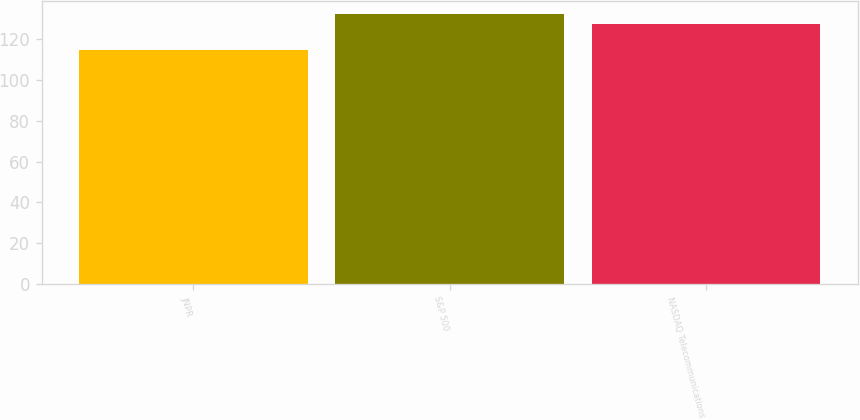Convert chart. <chart><loc_0><loc_0><loc_500><loc_500><bar_chart><fcel>JNPR<fcel>S&P 500<fcel>NASDAQ Telecommunications<nl><fcel>114.74<fcel>132.37<fcel>127.29<nl></chart> 